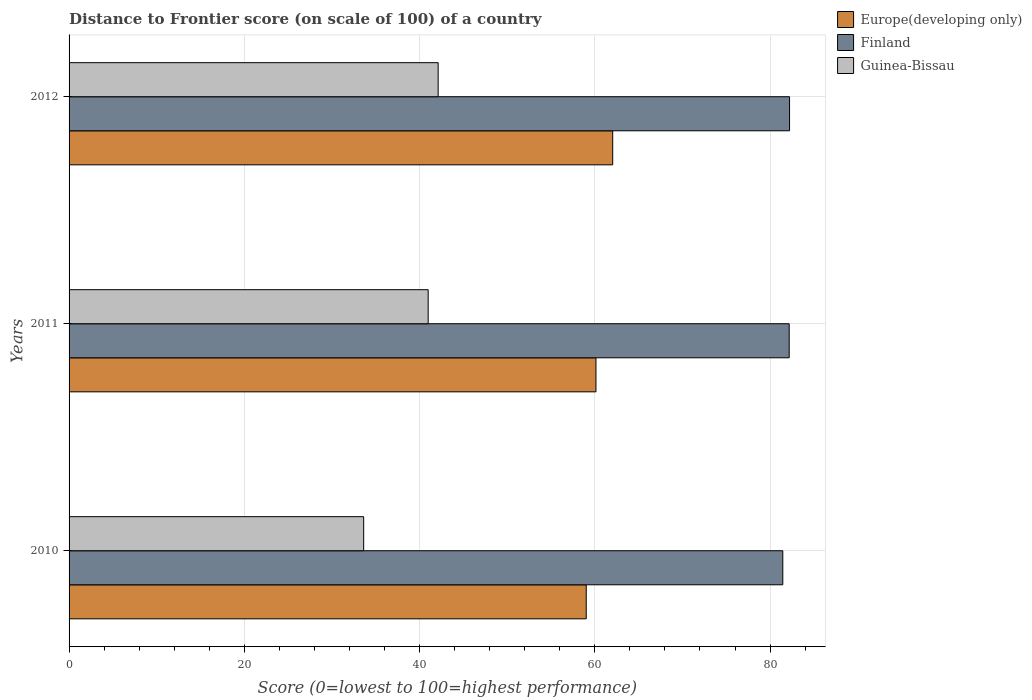How many groups of bars are there?
Keep it short and to the point. 3. Are the number of bars per tick equal to the number of legend labels?
Make the answer very short. Yes. Are the number of bars on each tick of the Y-axis equal?
Your response must be concise. Yes. What is the label of the 2nd group of bars from the top?
Offer a terse response. 2011. What is the distance to frontier score of in Finland in 2010?
Your answer should be very brief. 81.45. Across all years, what is the maximum distance to frontier score of in Finland?
Offer a terse response. 82.22. Across all years, what is the minimum distance to frontier score of in Guinea-Bissau?
Your answer should be compact. 33.62. What is the total distance to frontier score of in Europe(developing only) in the graph?
Provide a short and direct response. 181.19. What is the difference between the distance to frontier score of in Finland in 2010 and that in 2011?
Keep it short and to the point. -0.73. What is the difference between the distance to frontier score of in Guinea-Bissau in 2010 and the distance to frontier score of in Finland in 2012?
Keep it short and to the point. -48.6. What is the average distance to frontier score of in Europe(developing only) per year?
Your answer should be very brief. 60.4. In the year 2010, what is the difference between the distance to frontier score of in Finland and distance to frontier score of in Guinea-Bissau?
Your answer should be very brief. 47.83. What is the ratio of the distance to frontier score of in Finland in 2010 to that in 2011?
Ensure brevity in your answer.  0.99. Is the distance to frontier score of in Finland in 2011 less than that in 2012?
Offer a terse response. Yes. Is the difference between the distance to frontier score of in Finland in 2010 and 2012 greater than the difference between the distance to frontier score of in Guinea-Bissau in 2010 and 2012?
Your response must be concise. Yes. What is the difference between the highest and the second highest distance to frontier score of in Guinea-Bissau?
Ensure brevity in your answer.  1.14. What is the difference between the highest and the lowest distance to frontier score of in Europe(developing only)?
Provide a short and direct response. 3.02. What does the 1st bar from the top in 2010 represents?
Provide a short and direct response. Guinea-Bissau. What does the 1st bar from the bottom in 2010 represents?
Make the answer very short. Europe(developing only). Are the values on the major ticks of X-axis written in scientific E-notation?
Give a very brief answer. No. Does the graph contain any zero values?
Offer a very short reply. No. Does the graph contain grids?
Provide a short and direct response. Yes. Where does the legend appear in the graph?
Provide a short and direct response. Top right. What is the title of the graph?
Offer a terse response. Distance to Frontier score (on scale of 100) of a country. Does "Egypt, Arab Rep." appear as one of the legend labels in the graph?
Give a very brief answer. No. What is the label or title of the X-axis?
Give a very brief answer. Score (0=lowest to 100=highest performance). What is the label or title of the Y-axis?
Your answer should be very brief. Years. What is the Score (0=lowest to 100=highest performance) of Europe(developing only) in 2010?
Provide a short and direct response. 59.02. What is the Score (0=lowest to 100=highest performance) of Finland in 2010?
Make the answer very short. 81.45. What is the Score (0=lowest to 100=highest performance) in Guinea-Bissau in 2010?
Offer a terse response. 33.62. What is the Score (0=lowest to 100=highest performance) of Europe(developing only) in 2011?
Ensure brevity in your answer.  60.13. What is the Score (0=lowest to 100=highest performance) in Finland in 2011?
Your answer should be compact. 82.18. What is the Score (0=lowest to 100=highest performance) in Guinea-Bissau in 2011?
Ensure brevity in your answer.  40.98. What is the Score (0=lowest to 100=highest performance) of Europe(developing only) in 2012?
Your answer should be very brief. 62.04. What is the Score (0=lowest to 100=highest performance) in Finland in 2012?
Offer a very short reply. 82.22. What is the Score (0=lowest to 100=highest performance) in Guinea-Bissau in 2012?
Keep it short and to the point. 42.12. Across all years, what is the maximum Score (0=lowest to 100=highest performance) of Europe(developing only)?
Provide a short and direct response. 62.04. Across all years, what is the maximum Score (0=lowest to 100=highest performance) of Finland?
Your answer should be very brief. 82.22. Across all years, what is the maximum Score (0=lowest to 100=highest performance) of Guinea-Bissau?
Provide a succinct answer. 42.12. Across all years, what is the minimum Score (0=lowest to 100=highest performance) of Europe(developing only)?
Provide a succinct answer. 59.02. Across all years, what is the minimum Score (0=lowest to 100=highest performance) in Finland?
Your answer should be very brief. 81.45. Across all years, what is the minimum Score (0=lowest to 100=highest performance) in Guinea-Bissau?
Ensure brevity in your answer.  33.62. What is the total Score (0=lowest to 100=highest performance) of Europe(developing only) in the graph?
Ensure brevity in your answer.  181.19. What is the total Score (0=lowest to 100=highest performance) of Finland in the graph?
Provide a succinct answer. 245.85. What is the total Score (0=lowest to 100=highest performance) of Guinea-Bissau in the graph?
Keep it short and to the point. 116.72. What is the difference between the Score (0=lowest to 100=highest performance) in Europe(developing only) in 2010 and that in 2011?
Your answer should be compact. -1.11. What is the difference between the Score (0=lowest to 100=highest performance) of Finland in 2010 and that in 2011?
Offer a terse response. -0.73. What is the difference between the Score (0=lowest to 100=highest performance) in Guinea-Bissau in 2010 and that in 2011?
Keep it short and to the point. -7.36. What is the difference between the Score (0=lowest to 100=highest performance) of Europe(developing only) in 2010 and that in 2012?
Make the answer very short. -3.02. What is the difference between the Score (0=lowest to 100=highest performance) of Finland in 2010 and that in 2012?
Your answer should be compact. -0.77. What is the difference between the Score (0=lowest to 100=highest performance) in Guinea-Bissau in 2010 and that in 2012?
Provide a succinct answer. -8.5. What is the difference between the Score (0=lowest to 100=highest performance) of Europe(developing only) in 2011 and that in 2012?
Make the answer very short. -1.91. What is the difference between the Score (0=lowest to 100=highest performance) of Finland in 2011 and that in 2012?
Provide a short and direct response. -0.04. What is the difference between the Score (0=lowest to 100=highest performance) of Guinea-Bissau in 2011 and that in 2012?
Keep it short and to the point. -1.14. What is the difference between the Score (0=lowest to 100=highest performance) of Europe(developing only) in 2010 and the Score (0=lowest to 100=highest performance) of Finland in 2011?
Your answer should be compact. -23.16. What is the difference between the Score (0=lowest to 100=highest performance) in Europe(developing only) in 2010 and the Score (0=lowest to 100=highest performance) in Guinea-Bissau in 2011?
Your answer should be compact. 18.04. What is the difference between the Score (0=lowest to 100=highest performance) of Finland in 2010 and the Score (0=lowest to 100=highest performance) of Guinea-Bissau in 2011?
Ensure brevity in your answer.  40.47. What is the difference between the Score (0=lowest to 100=highest performance) in Europe(developing only) in 2010 and the Score (0=lowest to 100=highest performance) in Finland in 2012?
Keep it short and to the point. -23.2. What is the difference between the Score (0=lowest to 100=highest performance) of Europe(developing only) in 2010 and the Score (0=lowest to 100=highest performance) of Guinea-Bissau in 2012?
Keep it short and to the point. 16.9. What is the difference between the Score (0=lowest to 100=highest performance) in Finland in 2010 and the Score (0=lowest to 100=highest performance) in Guinea-Bissau in 2012?
Make the answer very short. 39.33. What is the difference between the Score (0=lowest to 100=highest performance) in Europe(developing only) in 2011 and the Score (0=lowest to 100=highest performance) in Finland in 2012?
Make the answer very short. -22.09. What is the difference between the Score (0=lowest to 100=highest performance) of Europe(developing only) in 2011 and the Score (0=lowest to 100=highest performance) of Guinea-Bissau in 2012?
Give a very brief answer. 18.01. What is the difference between the Score (0=lowest to 100=highest performance) in Finland in 2011 and the Score (0=lowest to 100=highest performance) in Guinea-Bissau in 2012?
Your answer should be very brief. 40.06. What is the average Score (0=lowest to 100=highest performance) of Europe(developing only) per year?
Provide a succinct answer. 60.4. What is the average Score (0=lowest to 100=highest performance) of Finland per year?
Your answer should be compact. 81.95. What is the average Score (0=lowest to 100=highest performance) in Guinea-Bissau per year?
Offer a very short reply. 38.91. In the year 2010, what is the difference between the Score (0=lowest to 100=highest performance) in Europe(developing only) and Score (0=lowest to 100=highest performance) in Finland?
Ensure brevity in your answer.  -22.43. In the year 2010, what is the difference between the Score (0=lowest to 100=highest performance) in Europe(developing only) and Score (0=lowest to 100=highest performance) in Guinea-Bissau?
Offer a very short reply. 25.4. In the year 2010, what is the difference between the Score (0=lowest to 100=highest performance) in Finland and Score (0=lowest to 100=highest performance) in Guinea-Bissau?
Your answer should be very brief. 47.83. In the year 2011, what is the difference between the Score (0=lowest to 100=highest performance) of Europe(developing only) and Score (0=lowest to 100=highest performance) of Finland?
Your answer should be compact. -22.05. In the year 2011, what is the difference between the Score (0=lowest to 100=highest performance) in Europe(developing only) and Score (0=lowest to 100=highest performance) in Guinea-Bissau?
Make the answer very short. 19.15. In the year 2011, what is the difference between the Score (0=lowest to 100=highest performance) in Finland and Score (0=lowest to 100=highest performance) in Guinea-Bissau?
Provide a short and direct response. 41.2. In the year 2012, what is the difference between the Score (0=lowest to 100=highest performance) in Europe(developing only) and Score (0=lowest to 100=highest performance) in Finland?
Ensure brevity in your answer.  -20.18. In the year 2012, what is the difference between the Score (0=lowest to 100=highest performance) in Europe(developing only) and Score (0=lowest to 100=highest performance) in Guinea-Bissau?
Give a very brief answer. 19.92. In the year 2012, what is the difference between the Score (0=lowest to 100=highest performance) of Finland and Score (0=lowest to 100=highest performance) of Guinea-Bissau?
Offer a very short reply. 40.1. What is the ratio of the Score (0=lowest to 100=highest performance) in Europe(developing only) in 2010 to that in 2011?
Make the answer very short. 0.98. What is the ratio of the Score (0=lowest to 100=highest performance) of Guinea-Bissau in 2010 to that in 2011?
Give a very brief answer. 0.82. What is the ratio of the Score (0=lowest to 100=highest performance) in Europe(developing only) in 2010 to that in 2012?
Give a very brief answer. 0.95. What is the ratio of the Score (0=lowest to 100=highest performance) of Finland in 2010 to that in 2012?
Ensure brevity in your answer.  0.99. What is the ratio of the Score (0=lowest to 100=highest performance) of Guinea-Bissau in 2010 to that in 2012?
Your response must be concise. 0.8. What is the ratio of the Score (0=lowest to 100=highest performance) in Europe(developing only) in 2011 to that in 2012?
Offer a terse response. 0.97. What is the ratio of the Score (0=lowest to 100=highest performance) in Finland in 2011 to that in 2012?
Offer a terse response. 1. What is the ratio of the Score (0=lowest to 100=highest performance) of Guinea-Bissau in 2011 to that in 2012?
Your answer should be very brief. 0.97. What is the difference between the highest and the second highest Score (0=lowest to 100=highest performance) in Europe(developing only)?
Offer a terse response. 1.91. What is the difference between the highest and the second highest Score (0=lowest to 100=highest performance) of Finland?
Keep it short and to the point. 0.04. What is the difference between the highest and the second highest Score (0=lowest to 100=highest performance) in Guinea-Bissau?
Offer a very short reply. 1.14. What is the difference between the highest and the lowest Score (0=lowest to 100=highest performance) in Europe(developing only)?
Your answer should be compact. 3.02. What is the difference between the highest and the lowest Score (0=lowest to 100=highest performance) of Finland?
Provide a succinct answer. 0.77. What is the difference between the highest and the lowest Score (0=lowest to 100=highest performance) in Guinea-Bissau?
Your answer should be very brief. 8.5. 